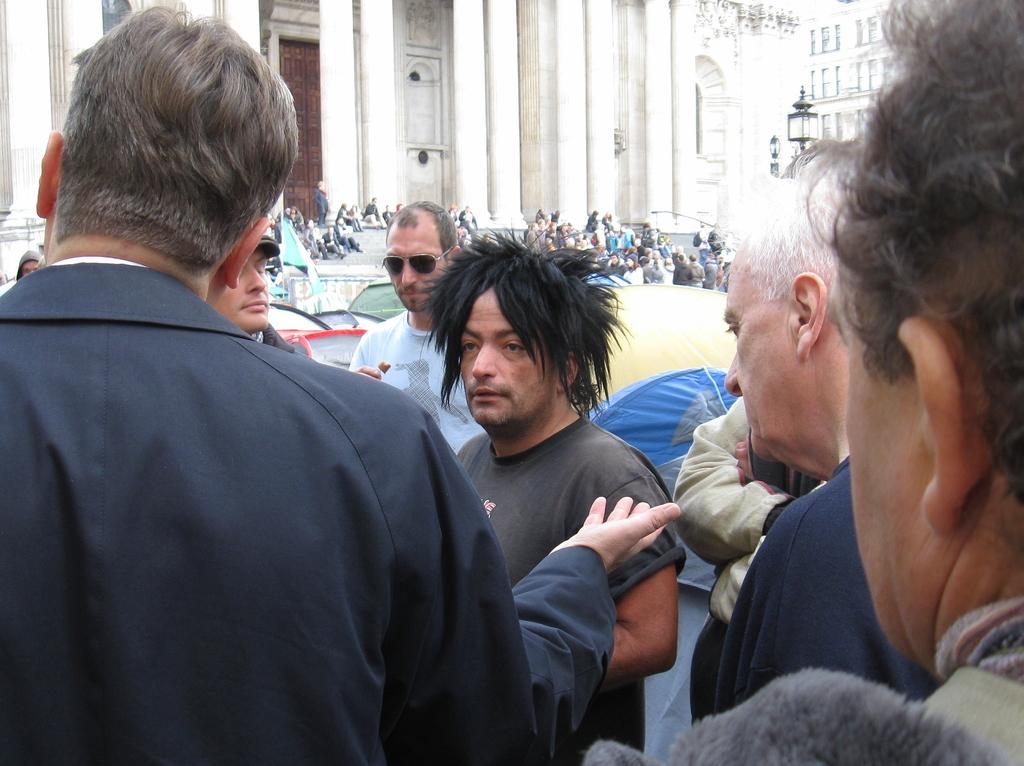How many people are present in the image? There are many people in the image. What can be seen in the background of the image? There is a building with pillars in the background. Where are some of the people located in the image? There are people sitting on the steps in the image. What type of sheet is being used to cover the furniture in the image? There is no sheet or furniture present in the image. How many shades of color can be seen on the people in the image? The provided facts do not mention the colors of the people's clothing or any shades of color. 